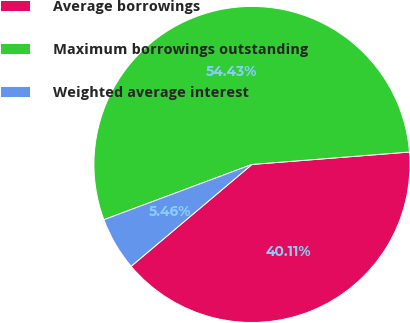Convert chart. <chart><loc_0><loc_0><loc_500><loc_500><pie_chart><fcel>Average borrowings<fcel>Maximum borrowings outstanding<fcel>Weighted average interest<nl><fcel>40.11%<fcel>54.43%<fcel>5.46%<nl></chart> 